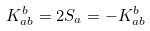<formula> <loc_0><loc_0><loc_500><loc_500>K ^ { b } _ { a b } = 2 S _ { a } = - K ^ { b } _ { a b }</formula> 